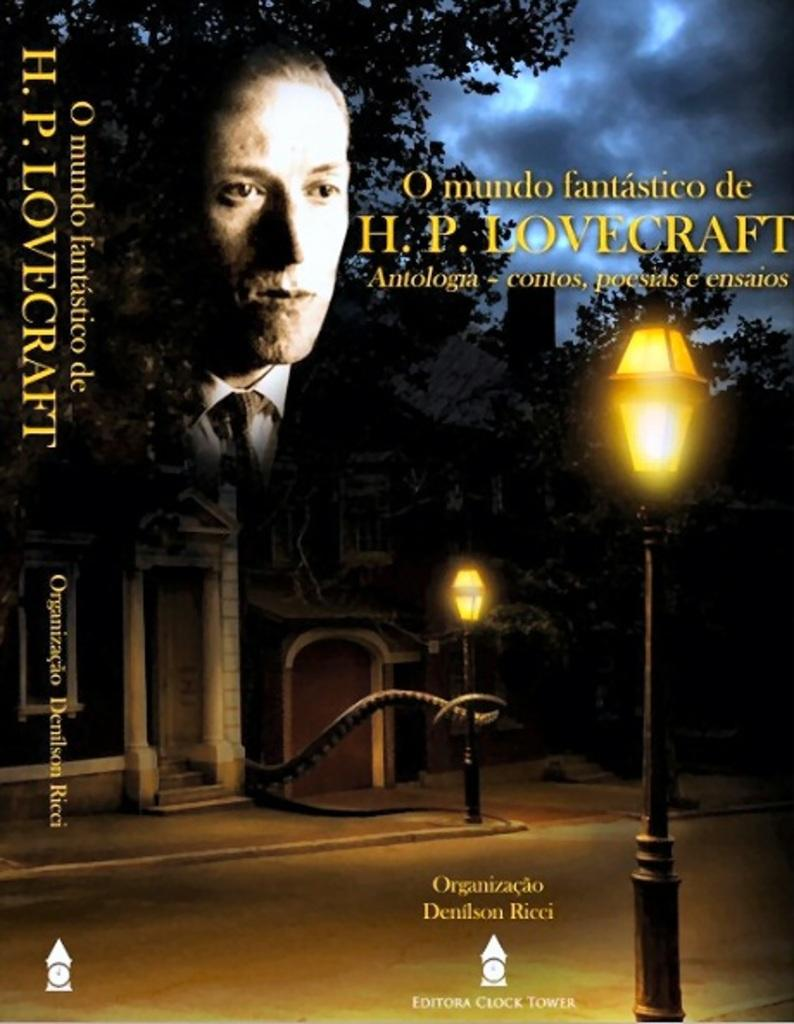Provide a one-sentence caption for the provided image. The film is a foreign one with the name H.P. LOVECRAFT attached to it. 